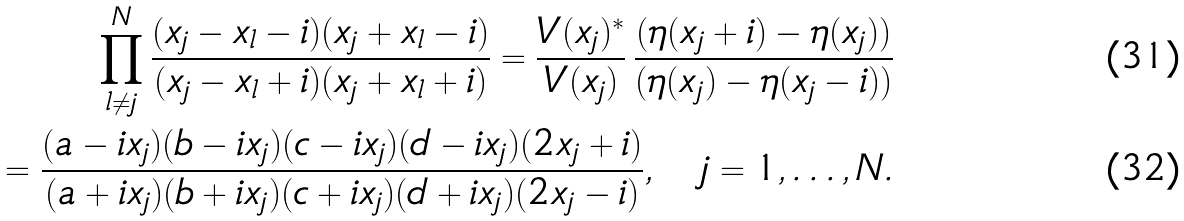<formula> <loc_0><loc_0><loc_500><loc_500>\prod _ { l \neq j } ^ { N } \frac { ( x _ { j } - x _ { l } - i ) ( x _ { j } + x _ { l } - i ) } { ( x _ { j } - x _ { l } + i ) ( x _ { j } + x _ { l } + i ) } = \frac { V ( x _ { j } ) ^ { * } } { V ( x _ { j } ) } \, \frac { ( \eta ( x _ { j } + i ) - \eta ( x _ { j } ) ) } { ( \eta ( x _ { j } ) - \eta ( x _ { j } - i ) ) } \\ = \frac { ( a - i x _ { j } ) ( b - i x _ { j } ) ( c - i x _ { j } ) ( d - i x _ { j } ) ( 2 x _ { j } + i ) } { ( a + i x _ { j } ) ( b + i x _ { j } ) ( c + i x _ { j } ) ( d + i x _ { j } ) ( 2 x _ { j } - i ) } , \quad j = 1 , \dots , N .</formula> 